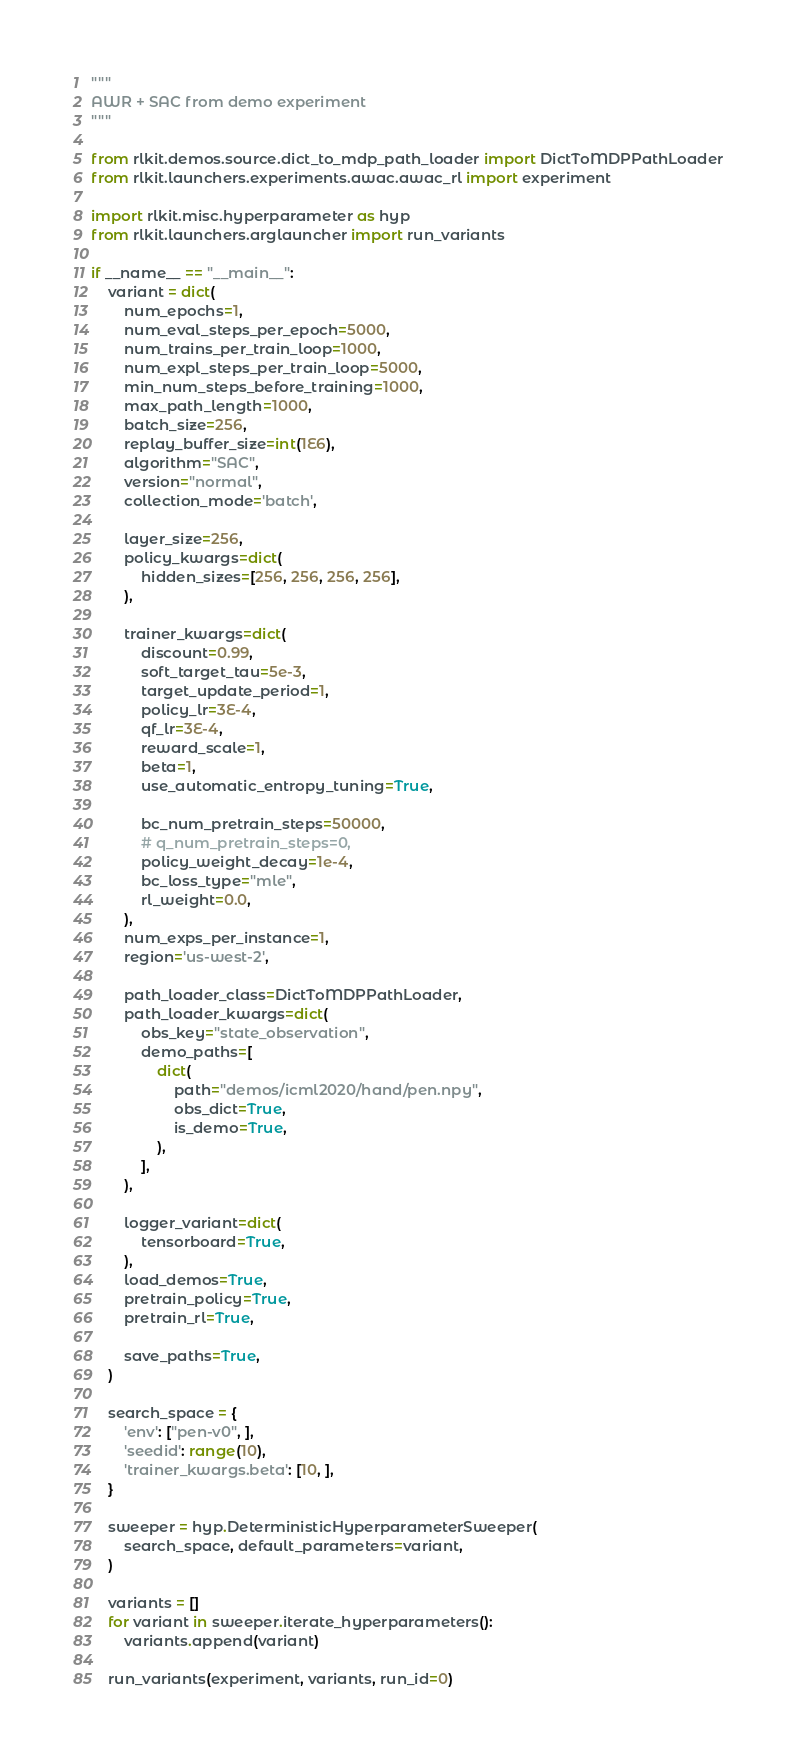Convert code to text. <code><loc_0><loc_0><loc_500><loc_500><_Python_>"""
AWR + SAC from demo experiment
"""

from rlkit.demos.source.dict_to_mdp_path_loader import DictToMDPPathLoader
from rlkit.launchers.experiments.awac.awac_rl import experiment

import rlkit.misc.hyperparameter as hyp
from rlkit.launchers.arglauncher import run_variants

if __name__ == "__main__":
    variant = dict(
        num_epochs=1,
        num_eval_steps_per_epoch=5000,
        num_trains_per_train_loop=1000,
        num_expl_steps_per_train_loop=5000,
        min_num_steps_before_training=1000,
        max_path_length=1000,
        batch_size=256,
        replay_buffer_size=int(1E6),
        algorithm="SAC",
        version="normal",
        collection_mode='batch',

        layer_size=256,
        policy_kwargs=dict(
            hidden_sizes=[256, 256, 256, 256],
        ),

        trainer_kwargs=dict(
            discount=0.99,
            soft_target_tau=5e-3,
            target_update_period=1,
            policy_lr=3E-4,
            qf_lr=3E-4,
            reward_scale=1,
            beta=1,
            use_automatic_entropy_tuning=True,

            bc_num_pretrain_steps=50000,
            # q_num_pretrain_steps=0,
            policy_weight_decay=1e-4,
            bc_loss_type="mle",
            rl_weight=0.0,
        ),
        num_exps_per_instance=1,
        region='us-west-2',

        path_loader_class=DictToMDPPathLoader,
        path_loader_kwargs=dict(
            obs_key="state_observation",
            demo_paths=[
                dict(
                    path="demos/icml2020/hand/pen.npy",
                    obs_dict=True,
                    is_demo=True,
                ),
            ],
        ),

        logger_variant=dict(
            tensorboard=True,
        ),
        load_demos=True,
        pretrain_policy=True,
        pretrain_rl=True,

        save_paths=True,
    )

    search_space = {
        'env': ["pen-v0", ],
        'seedid': range(10),
        'trainer_kwargs.beta': [10, ],
    }

    sweeper = hyp.DeterministicHyperparameterSweeper(
        search_space, default_parameters=variant,
    )

    variants = []
    for variant in sweeper.iterate_hyperparameters():
        variants.append(variant)

    run_variants(experiment, variants, run_id=0)
</code> 